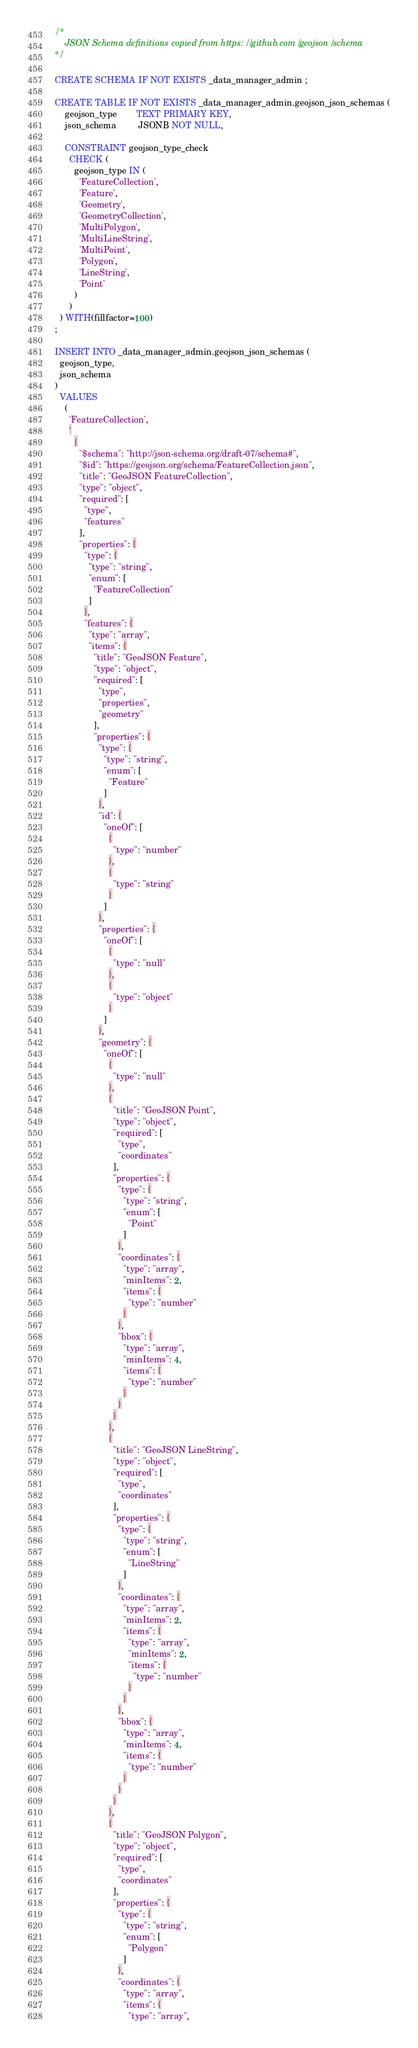<code> <loc_0><loc_0><loc_500><loc_500><_SQL_>/*
    JSON Schema definitions copied from https://github.com/geojson/schema
*/

CREATE SCHEMA IF NOT EXISTS _data_manager_admin ;

CREATE TABLE IF NOT EXISTS _data_manager_admin.geojson_json_schemas (
    geojson_type        TEXT PRIMARY KEY,
    json_schema         JSONB NOT NULL,

    CONSTRAINT geojson_type_check
      CHECK (
        geojson_type IN (
          'FeatureCollection',
          'Feature',
          'Geometry',
          'GeometryCollection',
          'MultiPolygon',
          'MultiLineString',
          'MultiPoint',
          'Polygon',
          'LineString',
          'Point'
        )
      )
  ) WITH(fillfactor=100)
;

INSERT INTO _data_manager_admin.geojson_json_schemas (
  geojson_type,
  json_schema
)
  VALUES
    (
      'FeatureCollection',
      '
        {
          "$schema": "http://json-schema.org/draft-07/schema#",
          "$id": "https://geojson.org/schema/FeatureCollection.json",
          "title": "GeoJSON FeatureCollection",
          "type": "object",
          "required": [
            "type",
            "features"
          ],
          "properties": {
            "type": {
              "type": "string",
              "enum": [
                "FeatureCollection"
              ]
            },
            "features": {
              "type": "array",
              "items": {
                "title": "GeoJSON Feature",
                "type": "object",
                "required": [
                  "type",
                  "properties",
                  "geometry"
                ],
                "properties": {
                  "type": {
                    "type": "string",
                    "enum": [
                      "Feature"
                    ]
                  },
                  "id": {
                    "oneOf": [
                      {
                        "type": "number"
                      },
                      {
                        "type": "string"
                      }
                    ]
                  },
                  "properties": {
                    "oneOf": [
                      {
                        "type": "null"
                      },
                      {
                        "type": "object"
                      }
                    ]
                  },
                  "geometry": {
                    "oneOf": [
                      {
                        "type": "null"
                      },
                      {
                        "title": "GeoJSON Point",
                        "type": "object",
                        "required": [
                          "type",
                          "coordinates"
                        ],
                        "properties": {
                          "type": {
                            "type": "string",
                            "enum": [
                              "Point"
                            ]
                          },
                          "coordinates": {
                            "type": "array",
                            "minItems": 2,
                            "items": {
                              "type": "number"
                            }
                          },
                          "bbox": {
                            "type": "array",
                            "minItems": 4,
                            "items": {
                              "type": "number"
                            }
                          }
                        }
                      },
                      {
                        "title": "GeoJSON LineString",
                        "type": "object",
                        "required": [
                          "type",
                          "coordinates"
                        ],
                        "properties": {
                          "type": {
                            "type": "string",
                            "enum": [
                              "LineString"
                            ]
                          },
                          "coordinates": {
                            "type": "array",
                            "minItems": 2,
                            "items": {
                              "type": "array",
                              "minItems": 2,
                              "items": {
                                "type": "number"
                              }
                            }
                          },
                          "bbox": {
                            "type": "array",
                            "minItems": 4,
                            "items": {
                              "type": "number"
                            }
                          }
                        }
                      },
                      {
                        "title": "GeoJSON Polygon",
                        "type": "object",
                        "required": [
                          "type",
                          "coordinates"
                        ],
                        "properties": {
                          "type": {
                            "type": "string",
                            "enum": [
                              "Polygon"
                            ]
                          },
                          "coordinates": {
                            "type": "array",
                            "items": {
                              "type": "array",</code> 